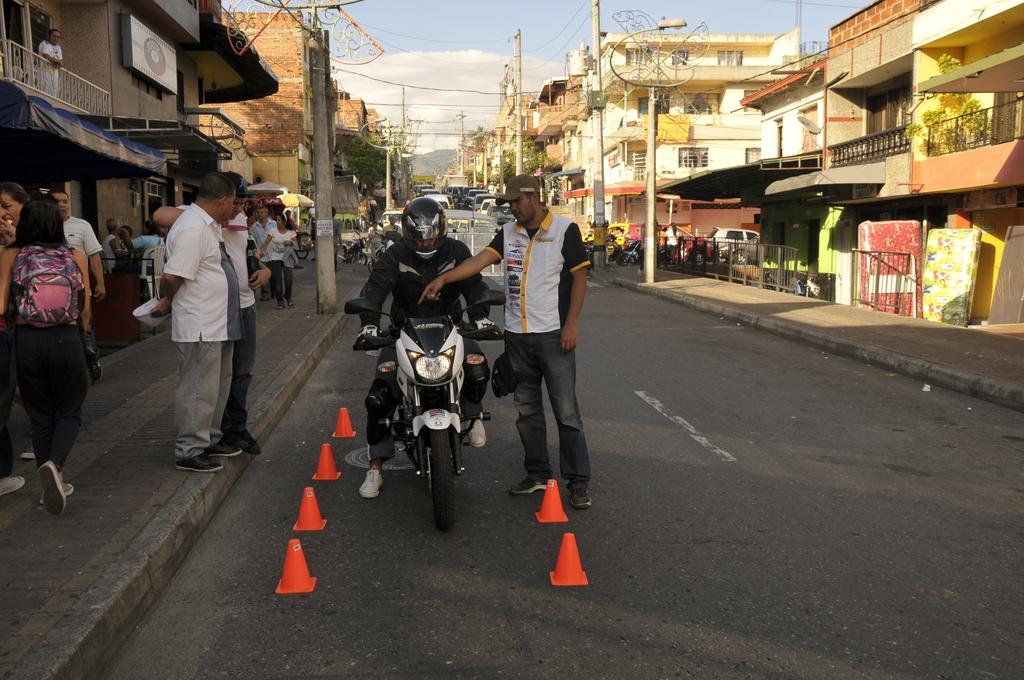What is the person in the image wearing? The person in the image is wearing a black dress. What is the person doing in the image? The person is sitting on a white bike. Who is around the person on the bike? There is a group of people beside the person on the bike. What do the people in the group have? The group of people have cars. What can be seen in the background of the image? There is a group of buildings in the background of the image. What type of clover is growing on the person's dress in the image? There is no clover visible on the person's dress in the image. 